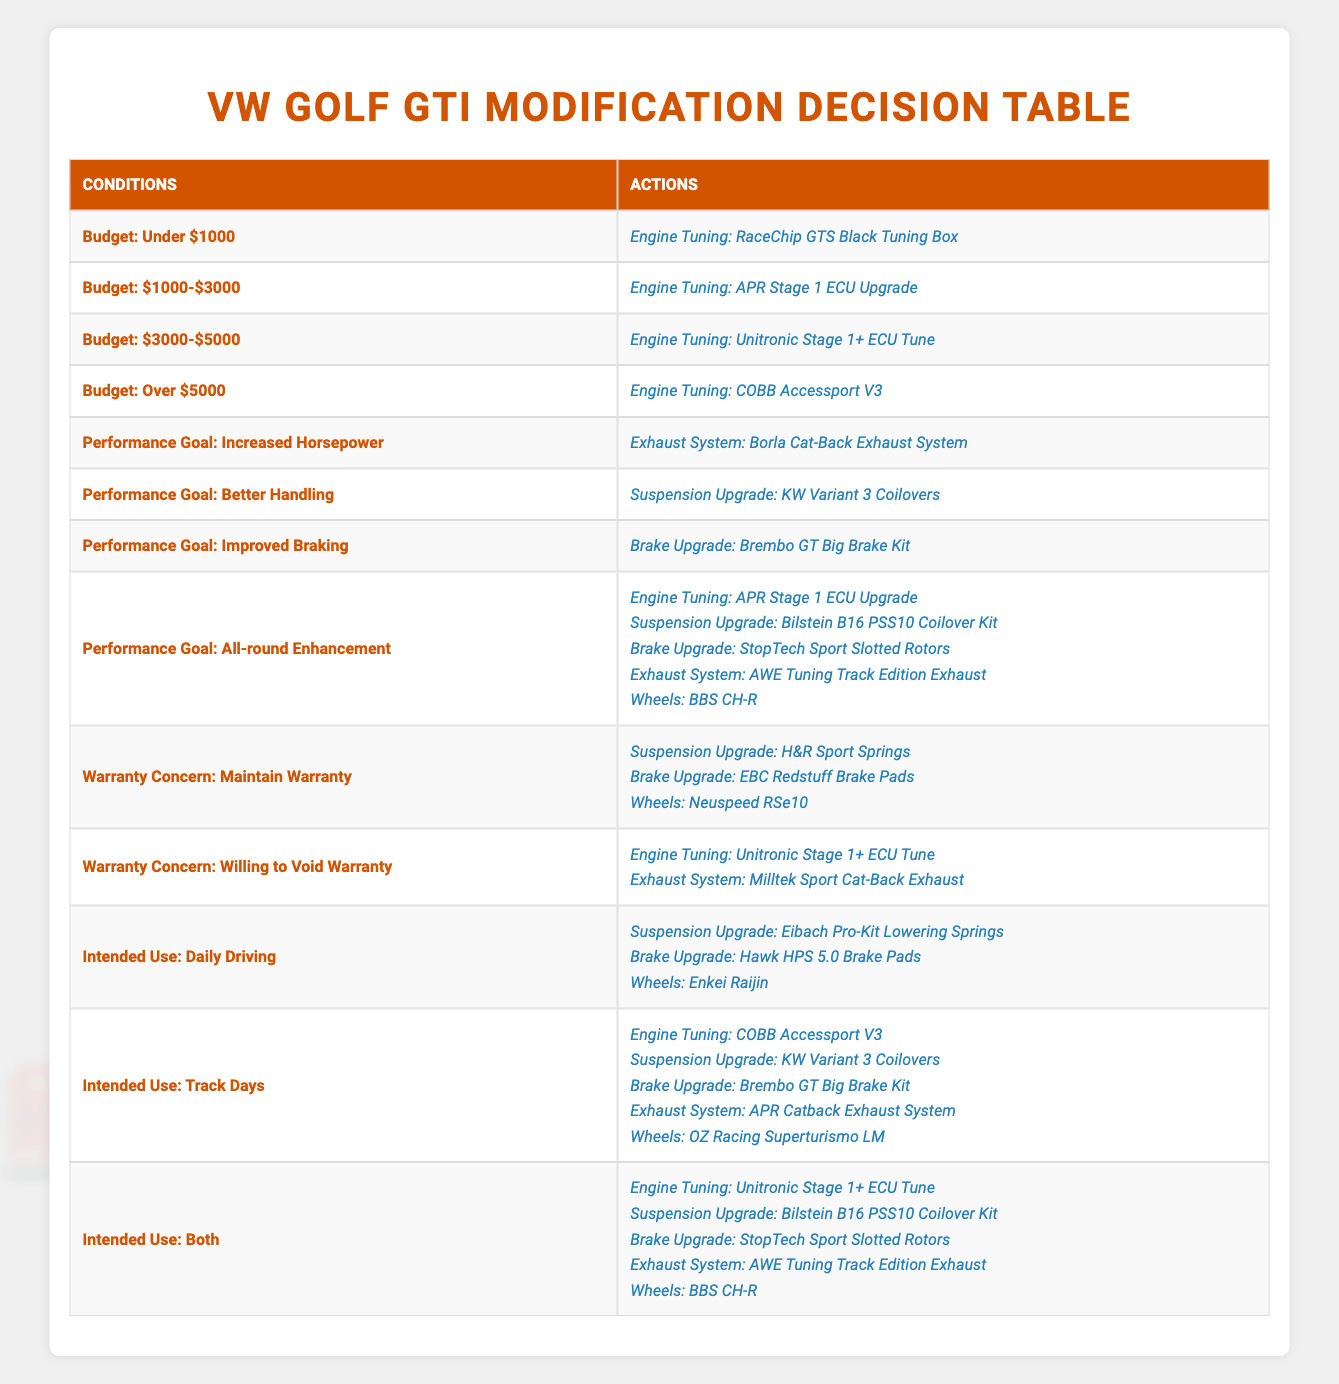What engine tuning option is available for a budget of $1000-$3000? In the table, under the condition for a budget of $1000-$3000, the listed engine tuning option is "APR Stage 1 ECU Upgrade."
Answer: APR Stage 1 ECU Upgrade How many suspension upgrade options are available for performance goals? Looking at the performance goals, there are two relevant actions listed: "Suspension Upgrade: KW Variant 3 Coilovers" for Better Handling, and "Suspension Upgrade: Bilstein B16 PSS10 Coilover Kit" for All-round Enhancement. Thus, there are 2 options.
Answer: 2 Is the "StopTech Sport Slotted Rotors" brake upgrade available for maintaining warranty? The table lists several brake upgrades under the condition "Warranty Concern: Maintain Warranty" and includes "EBC Redstuff Brake Pads," but not "StopTech Sport Slotted Rotors." Therefore, the statement is false.
Answer: No Which brake upgrade is recommended for improving braking performance? According to the table, under the condition for the performance goal "Improved Braking," the recommended action is "Brake Upgrade: Brembo GT Big Brake Kit."
Answer: Brembo GT Big Brake Kit What is the recommended modification combination for both track days and daily driving? The table states that for "Intended Use: Both," the actions listed are multiple: "Engine Tuning: Unitronic Stage 1+ ECU Tune," "Suspension Upgrade: Bilstein B16 PSS10 Coilover Kit," "Brake Upgrade: StopTech Sport Slotted Rotors," "Exhaust System: AWE Tuning Track Edition Exhaust," and "Wheels: BBS CH-R." This means a total of 5 modifications are recommended.
Answer: 5 modifications Under which budget can a person upgrade their exhaust system to the "Borla Cat-Back Exhaust System"? Referring to the performance goal, "Increased Horsepower," the table indicates that this exhaust system is the recommended action. Therefore, it does not specify a budget, making it applicable under various budgets, such as "$1000-$3000" or higher.
Answer: Various budgets Does the table recommend any wheels option for daily driving? Yes, under the "Intended Use: Daily Driving," the table includes "Wheels: Enkei Raijin" as a recommended action.
Answer: Yes What is the relationship between the budget of Over $5000 and the corresponding engine tuning option? For the budget of "Over $5000," the table specifies the action "Engine Tuning: COBB Accessport V3." This indicates that a higher budget allows for more premium tuning options.
Answer: COBB Accessport V3 